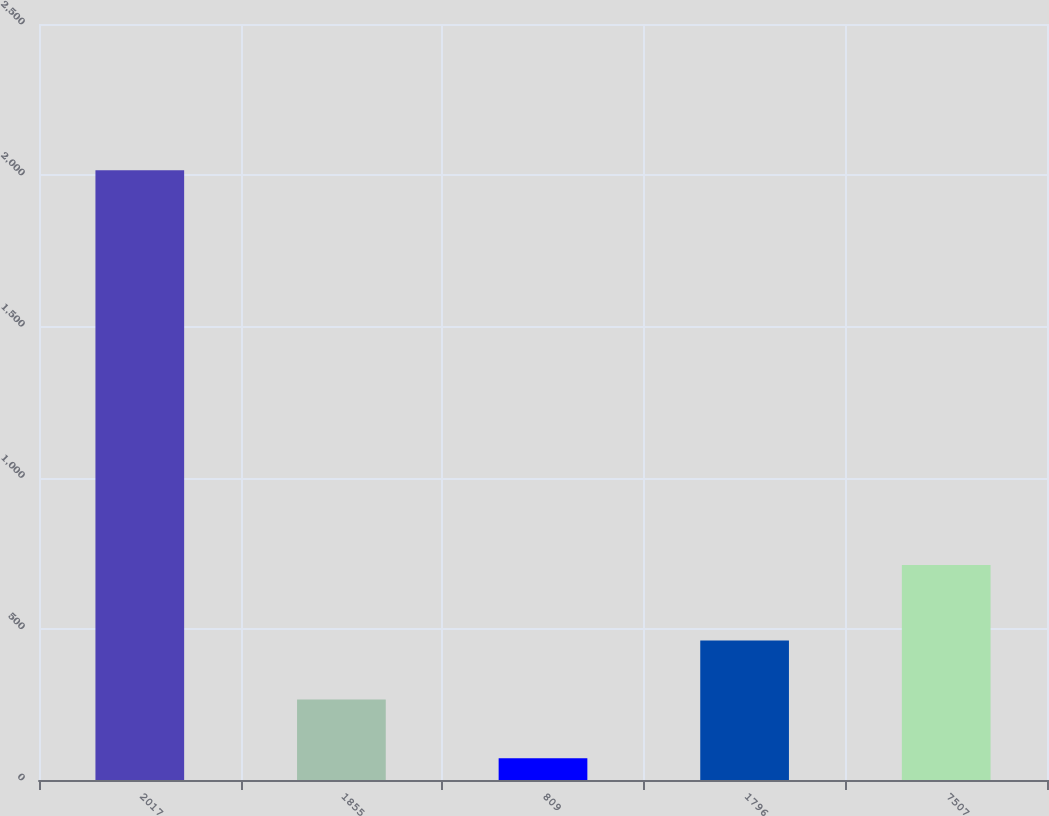Convert chart. <chart><loc_0><loc_0><loc_500><loc_500><bar_chart><fcel>2017<fcel>1855<fcel>809<fcel>1796<fcel>7507<nl><fcel>2016<fcel>266.58<fcel>72.2<fcel>460.96<fcel>711.3<nl></chart> 